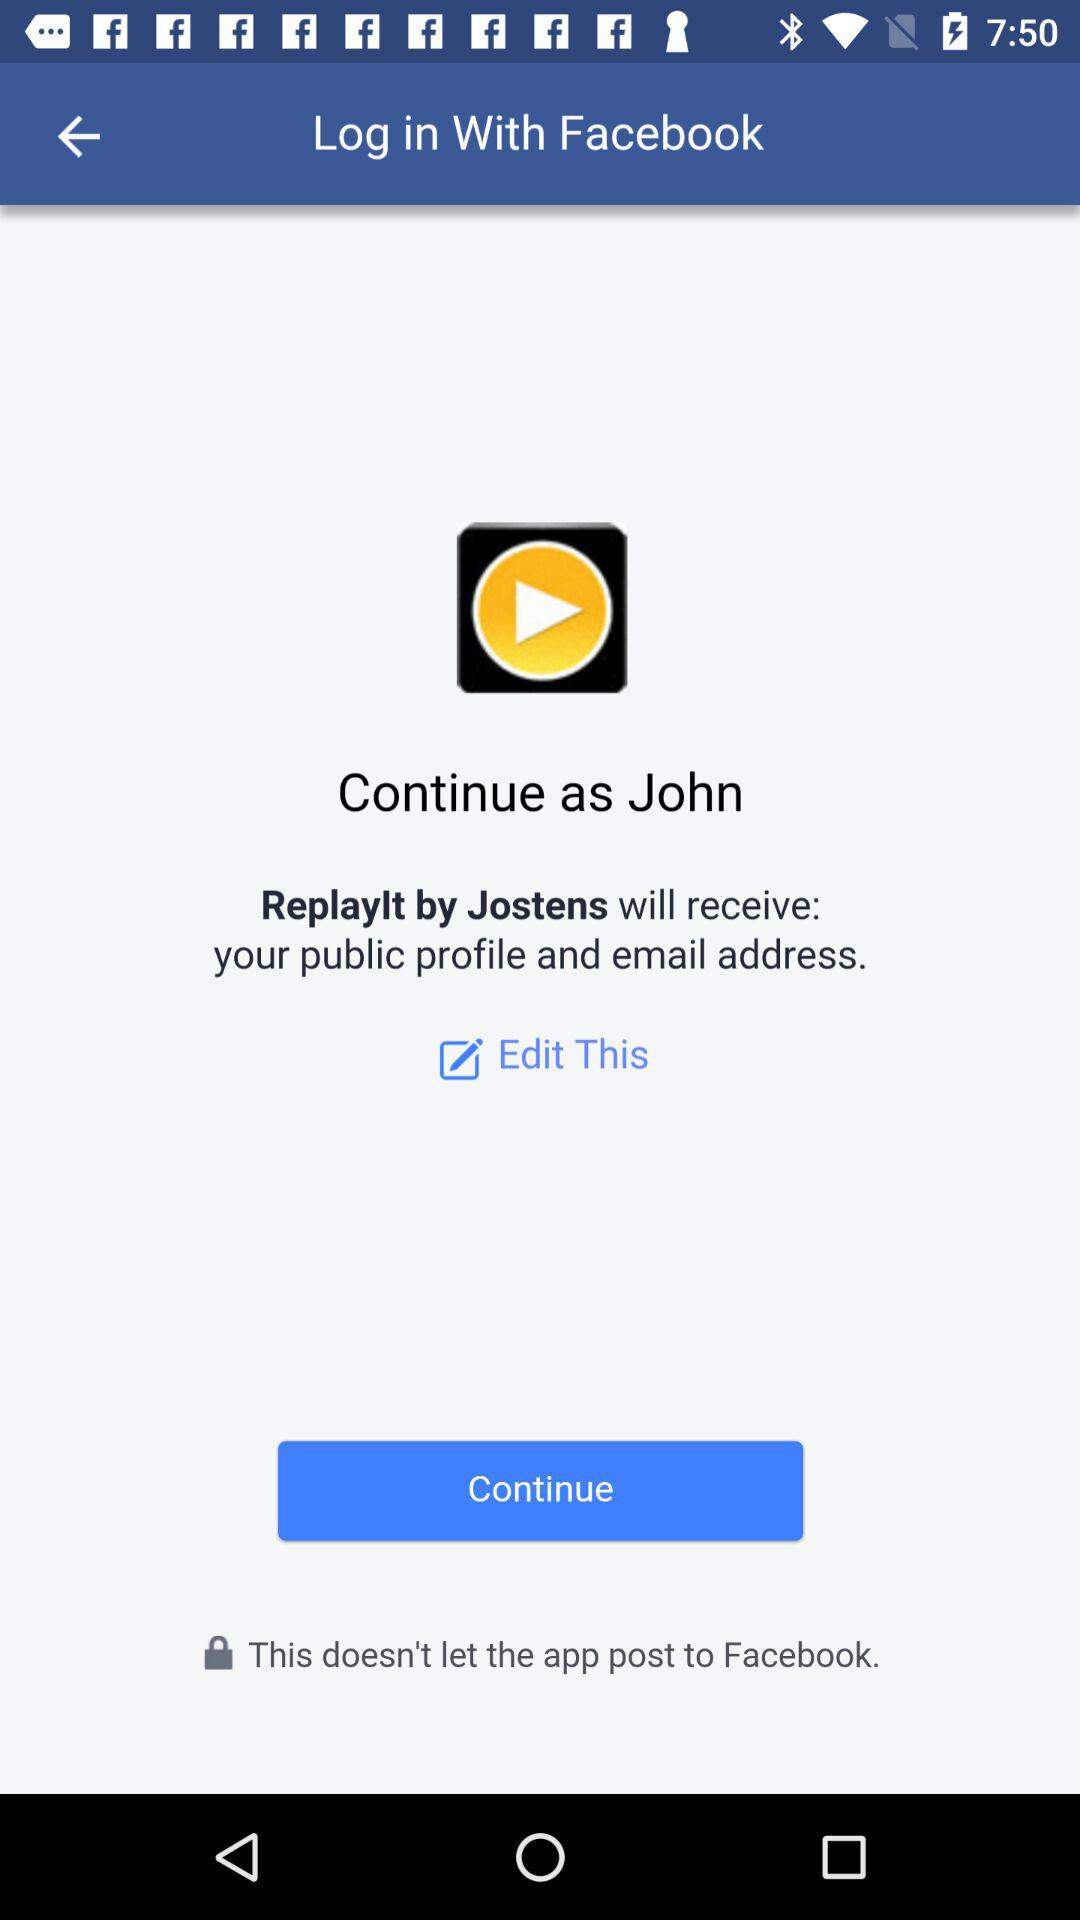What is the user name? The user name is "John". 